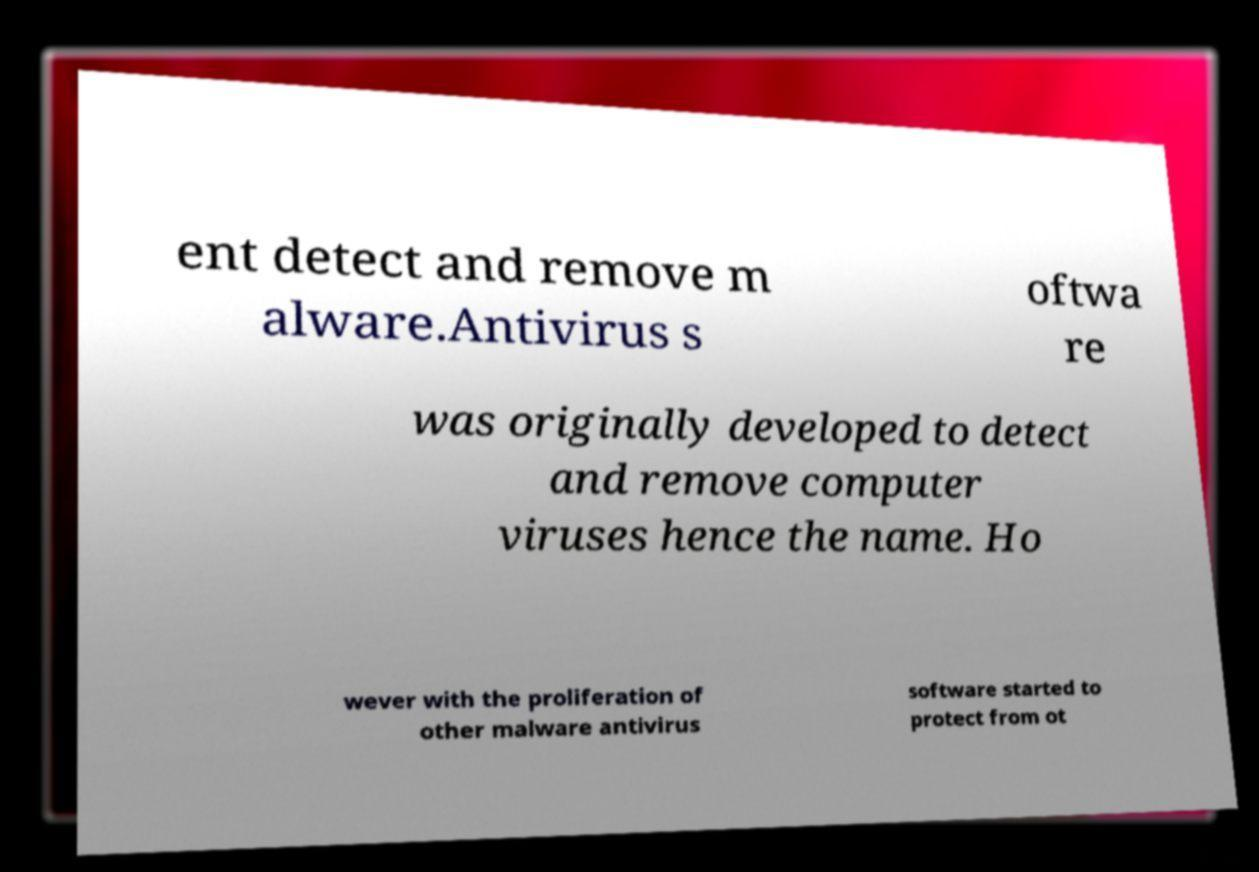For documentation purposes, I need the text within this image transcribed. Could you provide that? ent detect and remove m alware.Antivirus s oftwa re was originally developed to detect and remove computer viruses hence the name. Ho wever with the proliferation of other malware antivirus software started to protect from ot 